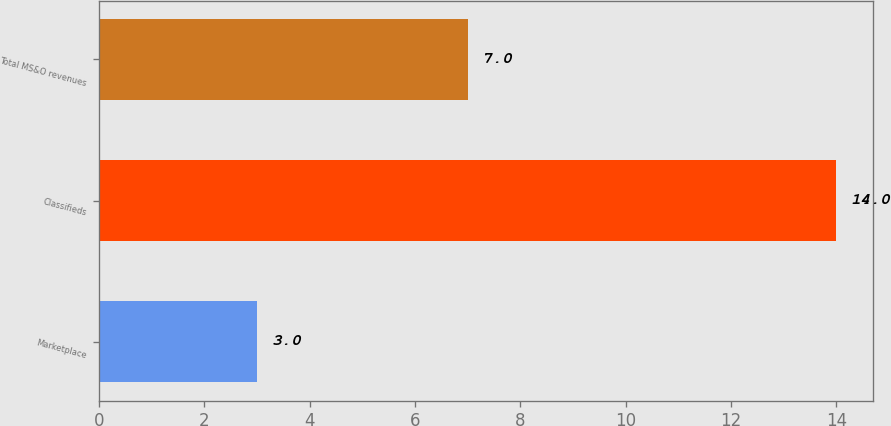<chart> <loc_0><loc_0><loc_500><loc_500><bar_chart><fcel>Marketplace<fcel>Classifieds<fcel>Total MS&O revenues<nl><fcel>3<fcel>14<fcel>7<nl></chart> 